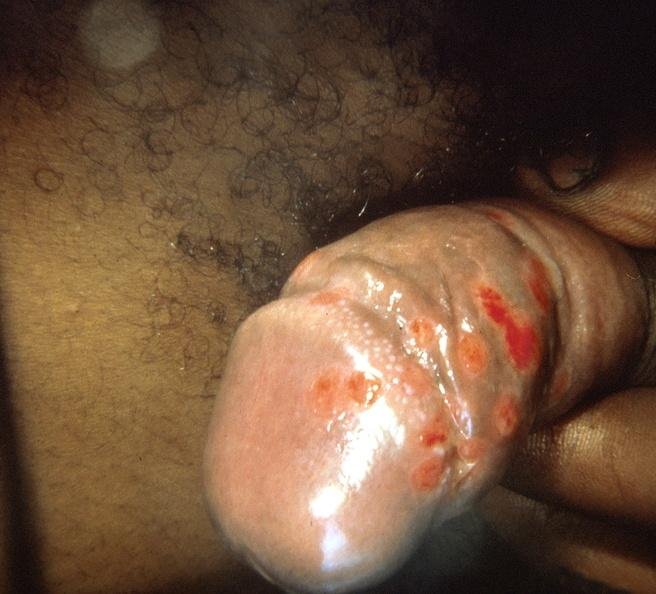what does this image show?
Answer the question using a single word or phrase. Penis 